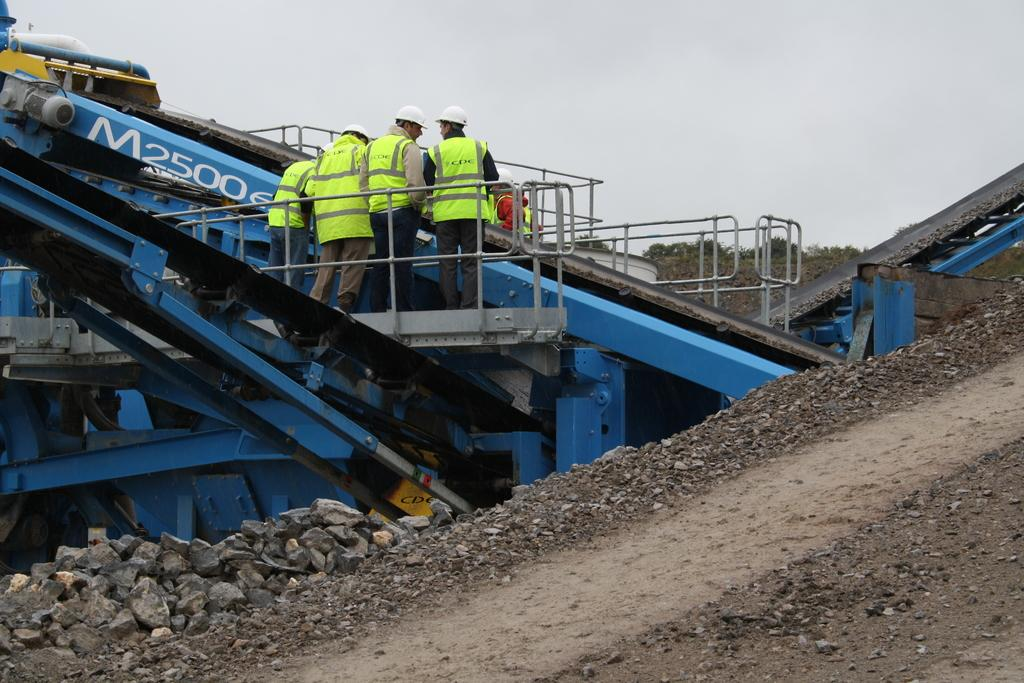Provide a one-sentence caption for the provided image. A piece of equipment has M2500 in white letters. 